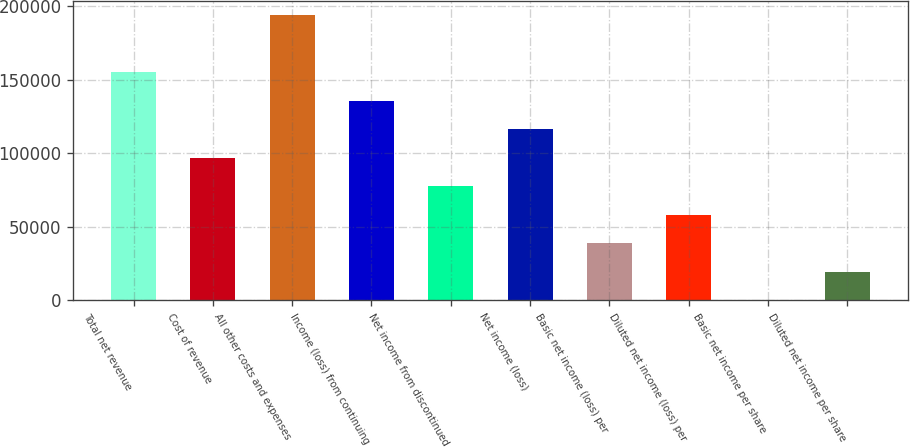Convert chart. <chart><loc_0><loc_0><loc_500><loc_500><bar_chart><fcel>Total net revenue<fcel>Cost of revenue<fcel>All other costs and expenses<fcel>Income (loss) from continuing<fcel>Net income from discontinued<fcel>Net income (loss)<fcel>Basic net income (loss) per<fcel>Diluted net income (loss) per<fcel>Basic net income per share<fcel>Diluted net income per share<nl><fcel>155142<fcel>96964<fcel>193928<fcel>135750<fcel>77571.2<fcel>116357<fcel>38785.6<fcel>58178.4<fcel>0.06<fcel>19392.8<nl></chart> 